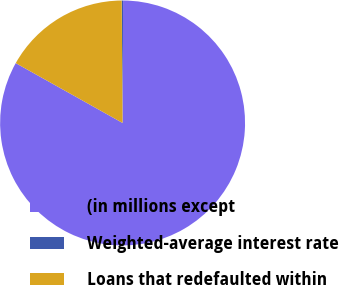Convert chart. <chart><loc_0><loc_0><loc_500><loc_500><pie_chart><fcel>(in millions except<fcel>Weighted-average interest rate<fcel>Loans that redefaulted within<nl><fcel>83.06%<fcel>0.18%<fcel>16.76%<nl></chart> 